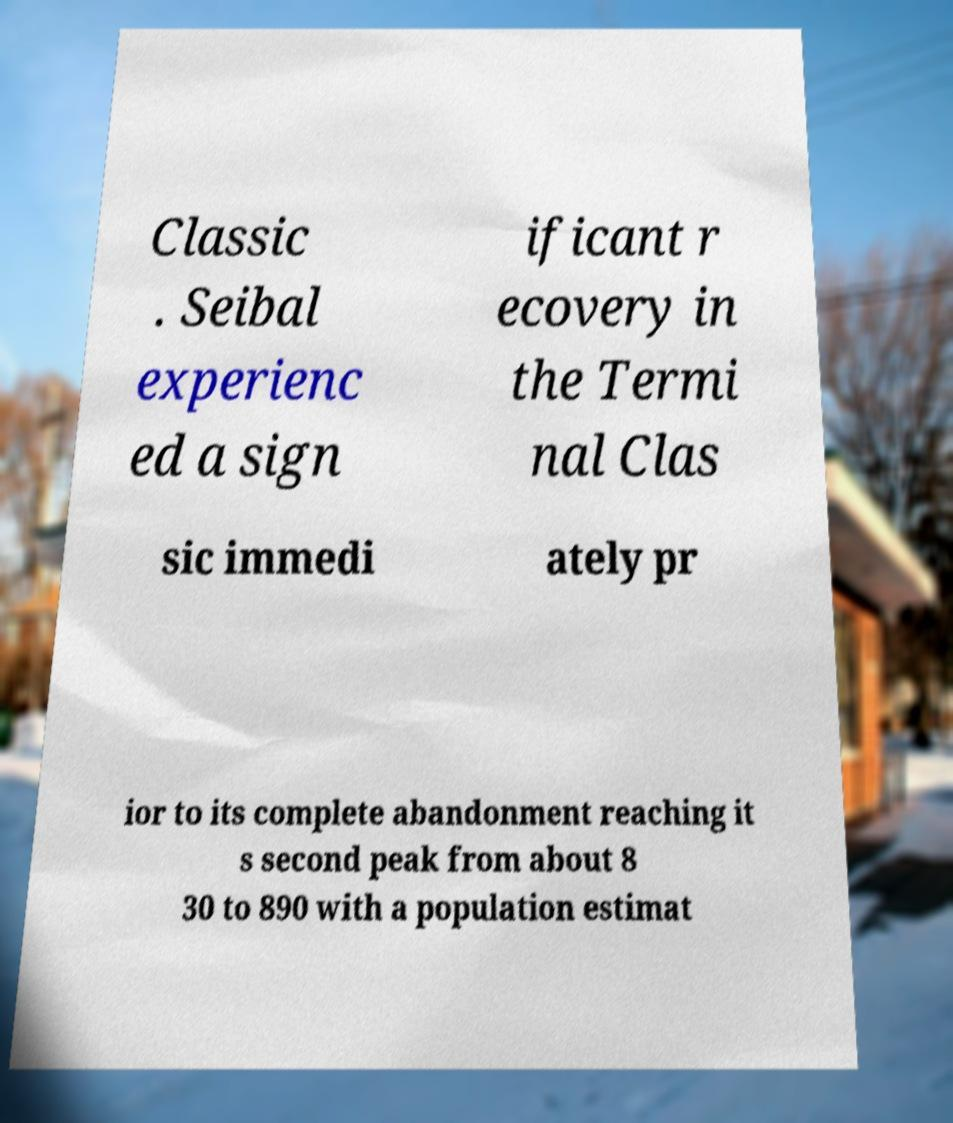Could you assist in decoding the text presented in this image and type it out clearly? Classic . Seibal experienc ed a sign ificant r ecovery in the Termi nal Clas sic immedi ately pr ior to its complete abandonment reaching it s second peak from about 8 30 to 890 with a population estimat 